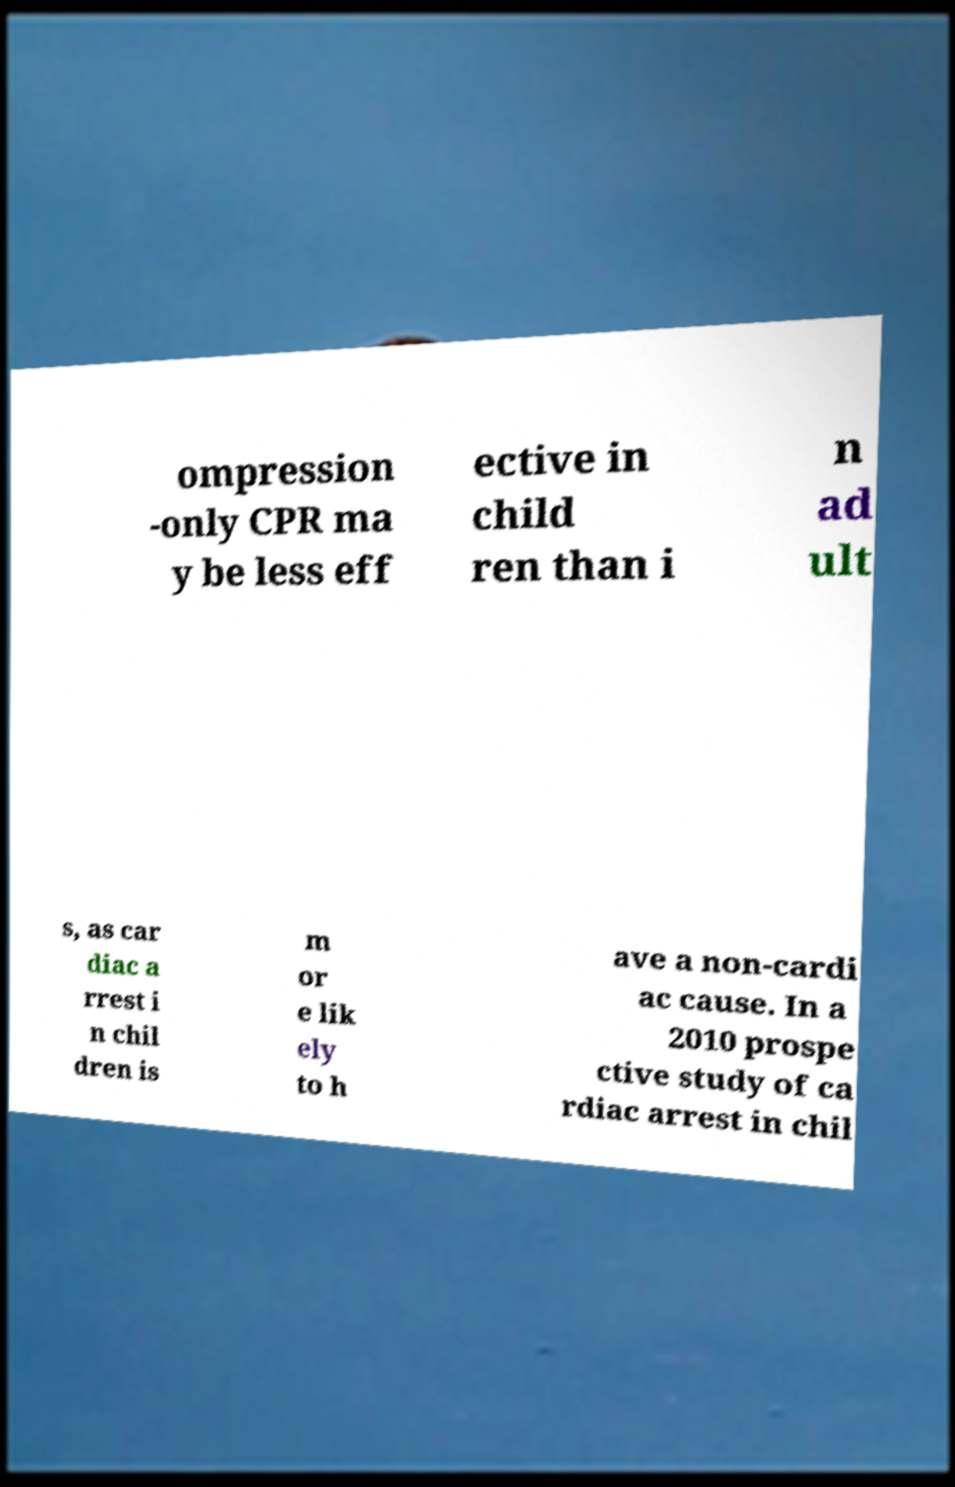There's text embedded in this image that I need extracted. Can you transcribe it verbatim? ompression -only CPR ma y be less eff ective in child ren than i n ad ult s, as car diac a rrest i n chil dren is m or e lik ely to h ave a non-cardi ac cause. In a 2010 prospe ctive study of ca rdiac arrest in chil 